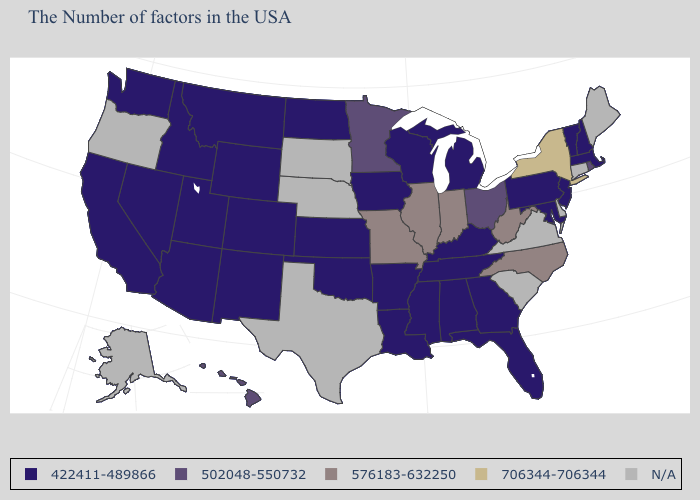What is the highest value in the MidWest ?
Short answer required. 576183-632250. Which states hav the highest value in the South?
Concise answer only. North Carolina, West Virginia. What is the value of North Carolina?
Concise answer only. 576183-632250. What is the value of Louisiana?
Quick response, please. 422411-489866. Name the states that have a value in the range N/A?
Quick response, please. Maine, Connecticut, Delaware, Virginia, South Carolina, Nebraska, Texas, South Dakota, Oregon, Alaska. Name the states that have a value in the range 422411-489866?
Short answer required. Massachusetts, New Hampshire, Vermont, New Jersey, Maryland, Pennsylvania, Florida, Georgia, Michigan, Kentucky, Alabama, Tennessee, Wisconsin, Mississippi, Louisiana, Arkansas, Iowa, Kansas, Oklahoma, North Dakota, Wyoming, Colorado, New Mexico, Utah, Montana, Arizona, Idaho, Nevada, California, Washington. Is the legend a continuous bar?
Keep it brief. No. Among the states that border Iowa , does Missouri have the highest value?
Write a very short answer. Yes. What is the value of Massachusetts?
Concise answer only. 422411-489866. Name the states that have a value in the range 422411-489866?
Short answer required. Massachusetts, New Hampshire, Vermont, New Jersey, Maryland, Pennsylvania, Florida, Georgia, Michigan, Kentucky, Alabama, Tennessee, Wisconsin, Mississippi, Louisiana, Arkansas, Iowa, Kansas, Oklahoma, North Dakota, Wyoming, Colorado, New Mexico, Utah, Montana, Arizona, Idaho, Nevada, California, Washington. What is the value of New Mexico?
Give a very brief answer. 422411-489866. What is the value of Hawaii?
Keep it brief. 502048-550732. 